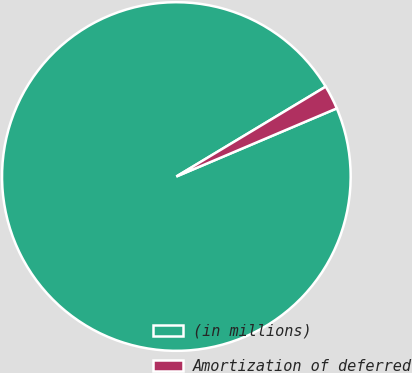<chart> <loc_0><loc_0><loc_500><loc_500><pie_chart><fcel>(in millions)<fcel>Amortization of deferred<nl><fcel>97.77%<fcel>2.23%<nl></chart> 